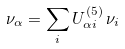Convert formula to latex. <formula><loc_0><loc_0><loc_500><loc_500>\nu _ { \alpha } = \sum _ { i } U ^ { ( 5 ) } _ { \alpha i } \, \nu _ { i }</formula> 